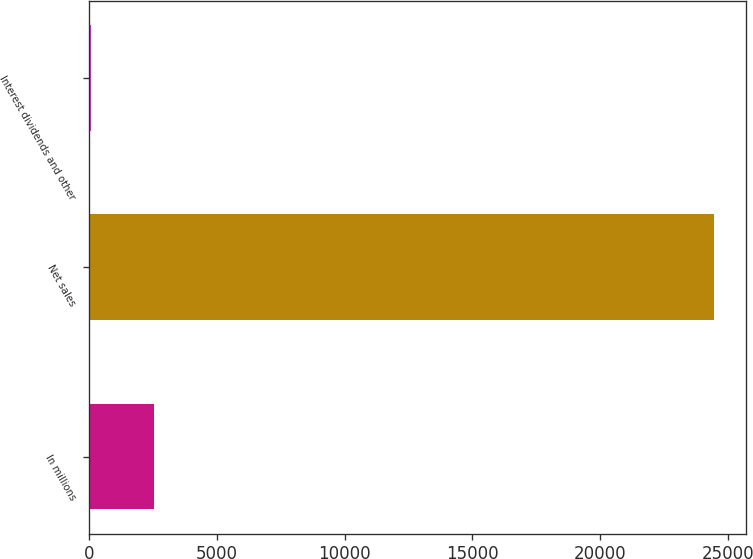Convert chart to OTSL. <chart><loc_0><loc_0><loc_500><loc_500><bar_chart><fcel>In millions<fcel>Net sales<fcel>Interest dividends and other<nl><fcel>2540.9<fcel>24455<fcel>106<nl></chart> 